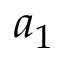Convert formula to latex. <formula><loc_0><loc_0><loc_500><loc_500>a _ { 1 }</formula> 